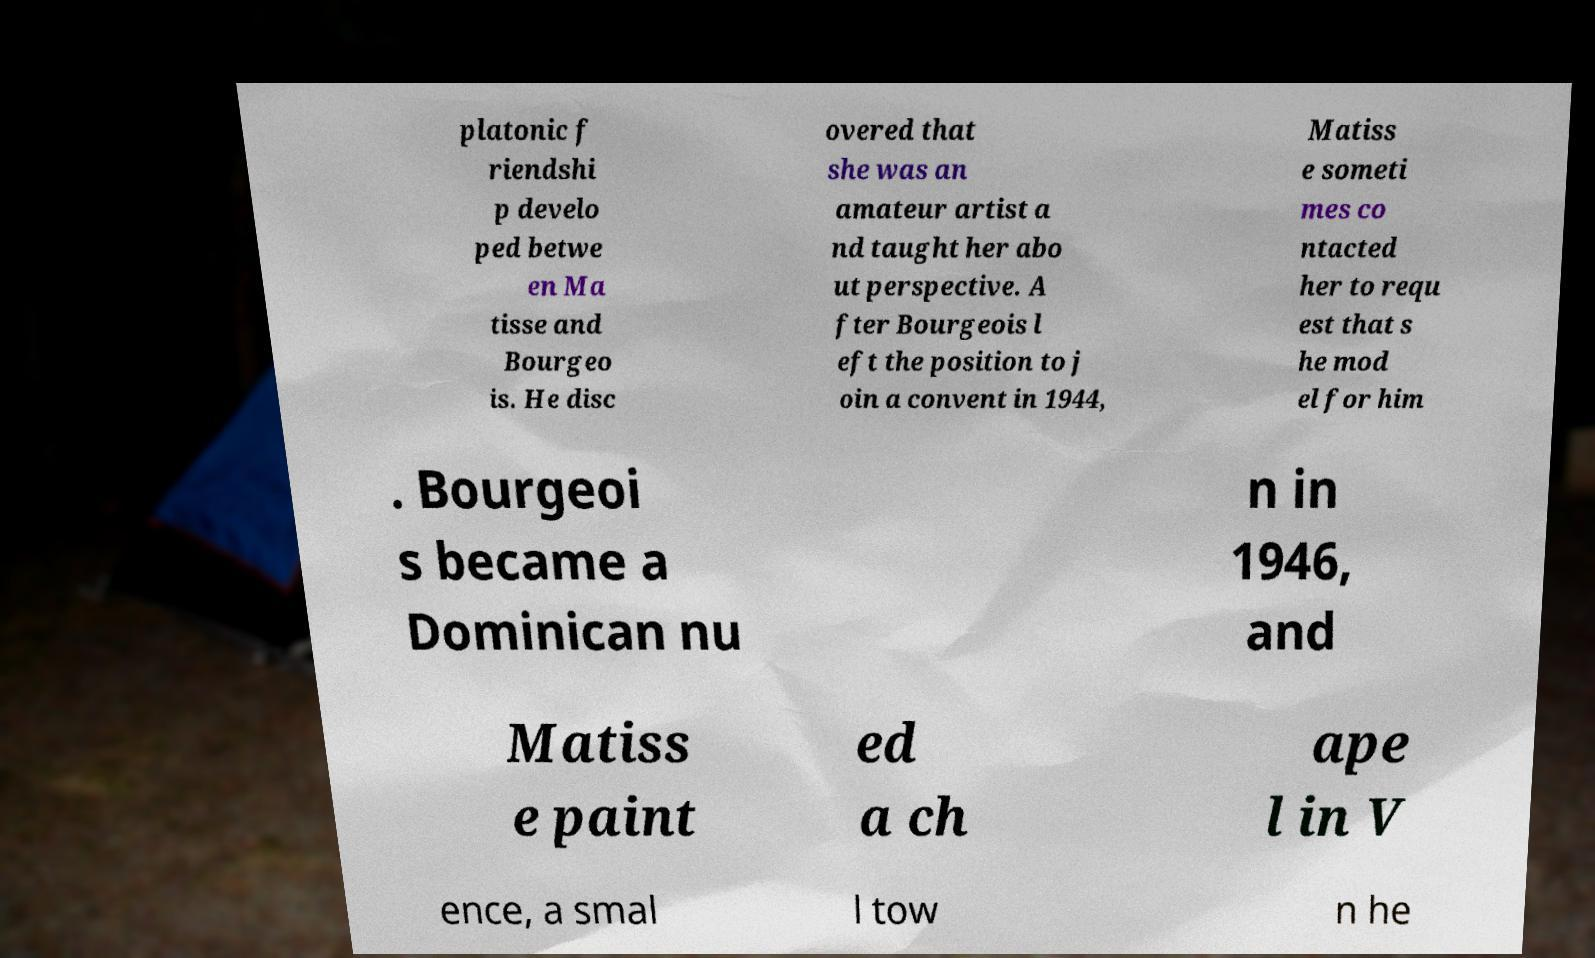Please identify and transcribe the text found in this image. platonic f riendshi p develo ped betwe en Ma tisse and Bourgeo is. He disc overed that she was an amateur artist a nd taught her abo ut perspective. A fter Bourgeois l eft the position to j oin a convent in 1944, Matiss e someti mes co ntacted her to requ est that s he mod el for him . Bourgeoi s became a Dominican nu n in 1946, and Matiss e paint ed a ch ape l in V ence, a smal l tow n he 